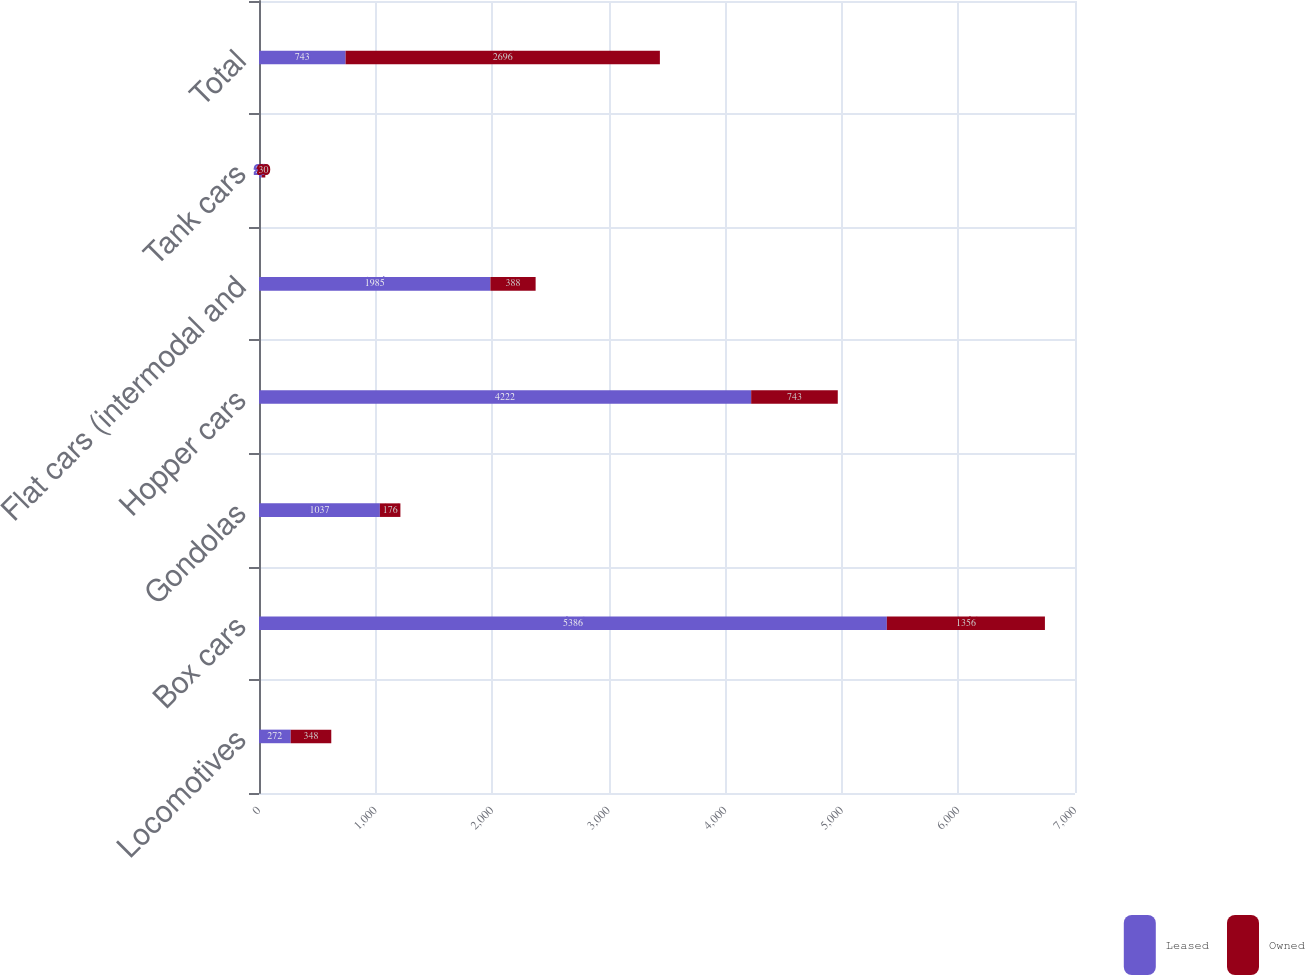Convert chart to OTSL. <chart><loc_0><loc_0><loc_500><loc_500><stacked_bar_chart><ecel><fcel>Locomotives<fcel>Box cars<fcel>Gondolas<fcel>Hopper cars<fcel>Flat cars (intermodal and<fcel>Tank cars<fcel>Total<nl><fcel>Leased<fcel>272<fcel>5386<fcel>1037<fcel>4222<fcel>1985<fcel>24<fcel>743<nl><fcel>Owned<fcel>348<fcel>1356<fcel>176<fcel>743<fcel>388<fcel>30<fcel>2696<nl></chart> 